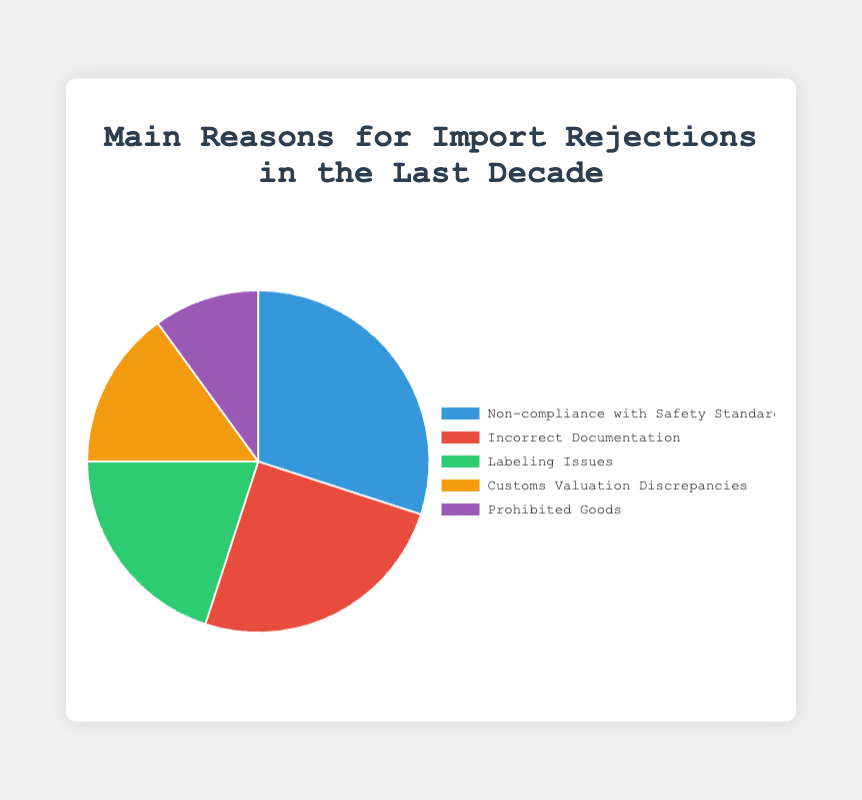What is the most common reason for import rejections? The most common reason for import rejections is represented by the largest slice of the pie chart. From the provided information, "Non-compliance with Safety Standards" occupies 30% of the chart, making it the most common reason.
Answer: Non-compliance with Safety Standards Which two rejection reasons combined have the highest percentage? To find the two rejection reasons with the highest combined percentage, we sum the percentages of the top two reasons. "Non-compliance with Safety Standards" has 30% and "Incorrect Documentation" has 25%. So, their combined percentage is 30% + 25% = 55%.
Answer: Non-compliance with Safety Standards and Incorrect Documentation What percentage of import rejections is due to Non-compliance with Safety Standards and Labeling Issues combined? We sum the percentages of "Non-compliance with Safety Standards" (30%) and "Labeling Issues" (20%). Thus, 30% + 20% = 50%.
Answer: 50% Which reason is less common: Labeling Issues or Customs Valuation Discrepancies? Comparing the percentages of the two reasons: "Labeling Issues" has 20%, while "Customs Valuation Discrepancies" has 15%. Since 15% is less than 20%, "Customs Valuation Discrepancies" is less common.
Answer: Customs Valuation Discrepancies What is the difference in percentage between the highest and lowest rejection reasons? The highest rejection reason is "Non-compliance with Safety Standards" at 30%, and the lowest is "Prohibited Goods" at 10%. The difference is computed as 30% - 10% = 20%.
Answer: 20% What fraction of the import rejections is due to Incorrect Documentation? "Incorrect Documentation" accounts for 25% of the import rejections. The fraction representing this value is 25/100, which simplifies to 1/4.
Answer: 1/4 Which two reasons for import rejections together represent exactly half of the chart? No single pair of reasons sums to exactly 50%. However, summing "Non-compliance with Safety Standards" (30%) and "Labeling Issues" (20%) results in 30% + 20% = 50%, which is half of the chart.
Answer: Non-compliance with Safety Standards and Labeling Issues Which slice of the pie chart is represented by the color red? According to the provided color scheme, "Incorrect Documentation" is represented by the color red.
Answer: Incorrect Documentation 